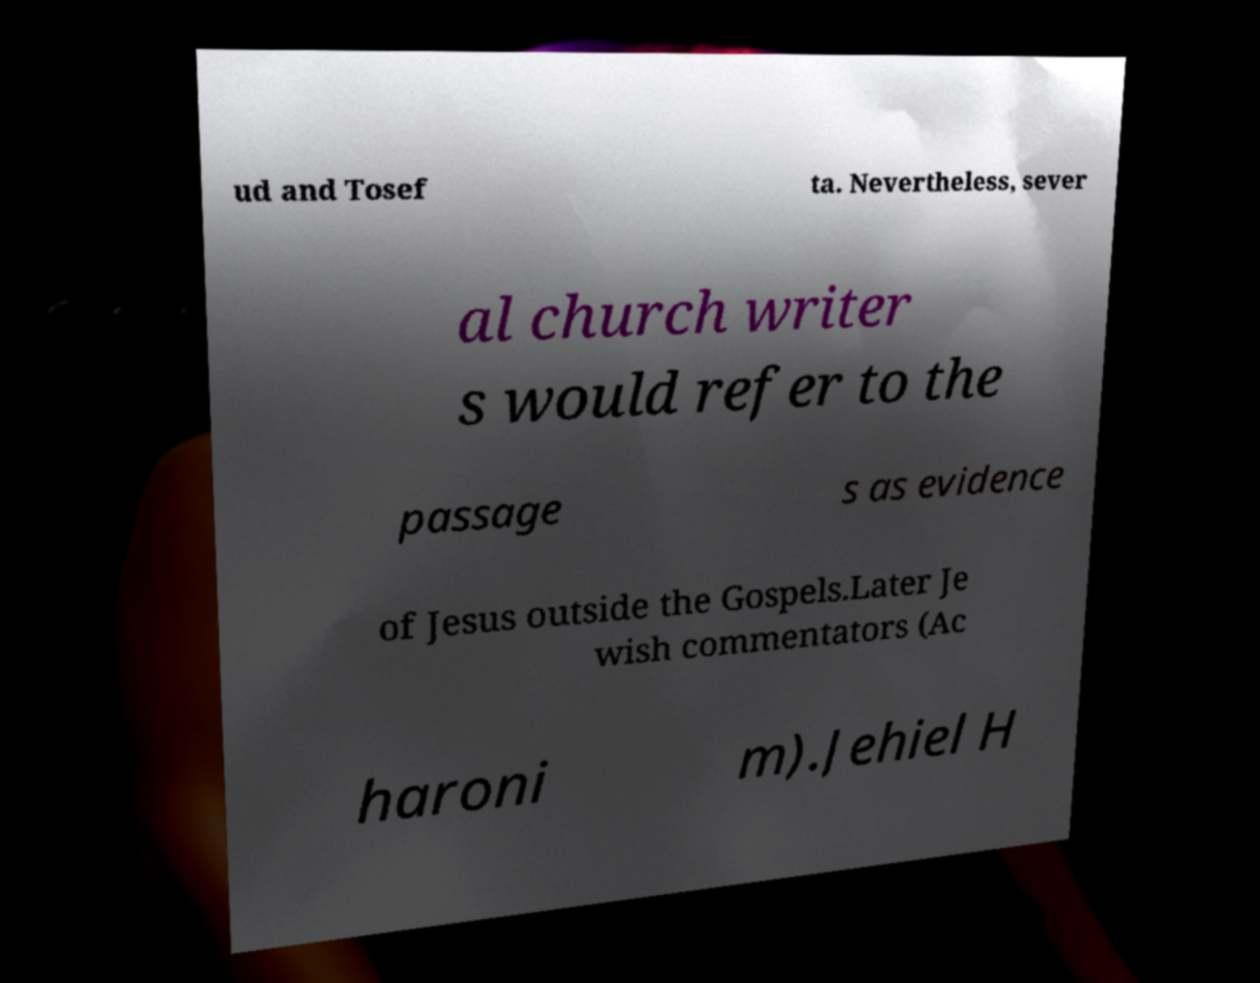I need the written content from this picture converted into text. Can you do that? ud and Tosef ta. Nevertheless, sever al church writer s would refer to the passage s as evidence of Jesus outside the Gospels.Later Je wish commentators (Ac haroni m).Jehiel H 